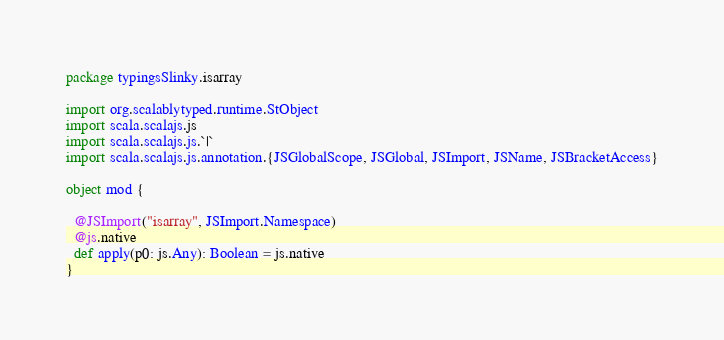<code> <loc_0><loc_0><loc_500><loc_500><_Scala_>package typingsSlinky.isarray

import org.scalablytyped.runtime.StObject
import scala.scalajs.js
import scala.scalajs.js.`|`
import scala.scalajs.js.annotation.{JSGlobalScope, JSGlobal, JSImport, JSName, JSBracketAccess}

object mod {
  
  @JSImport("isarray", JSImport.Namespace)
  @js.native
  def apply(p0: js.Any): Boolean = js.native
}
</code> 